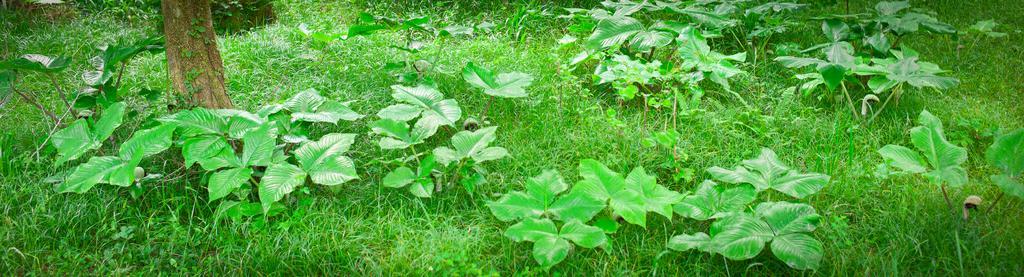Can you describe this image briefly? In the image there are many plants on the grassland and there is a tree on the left side. 